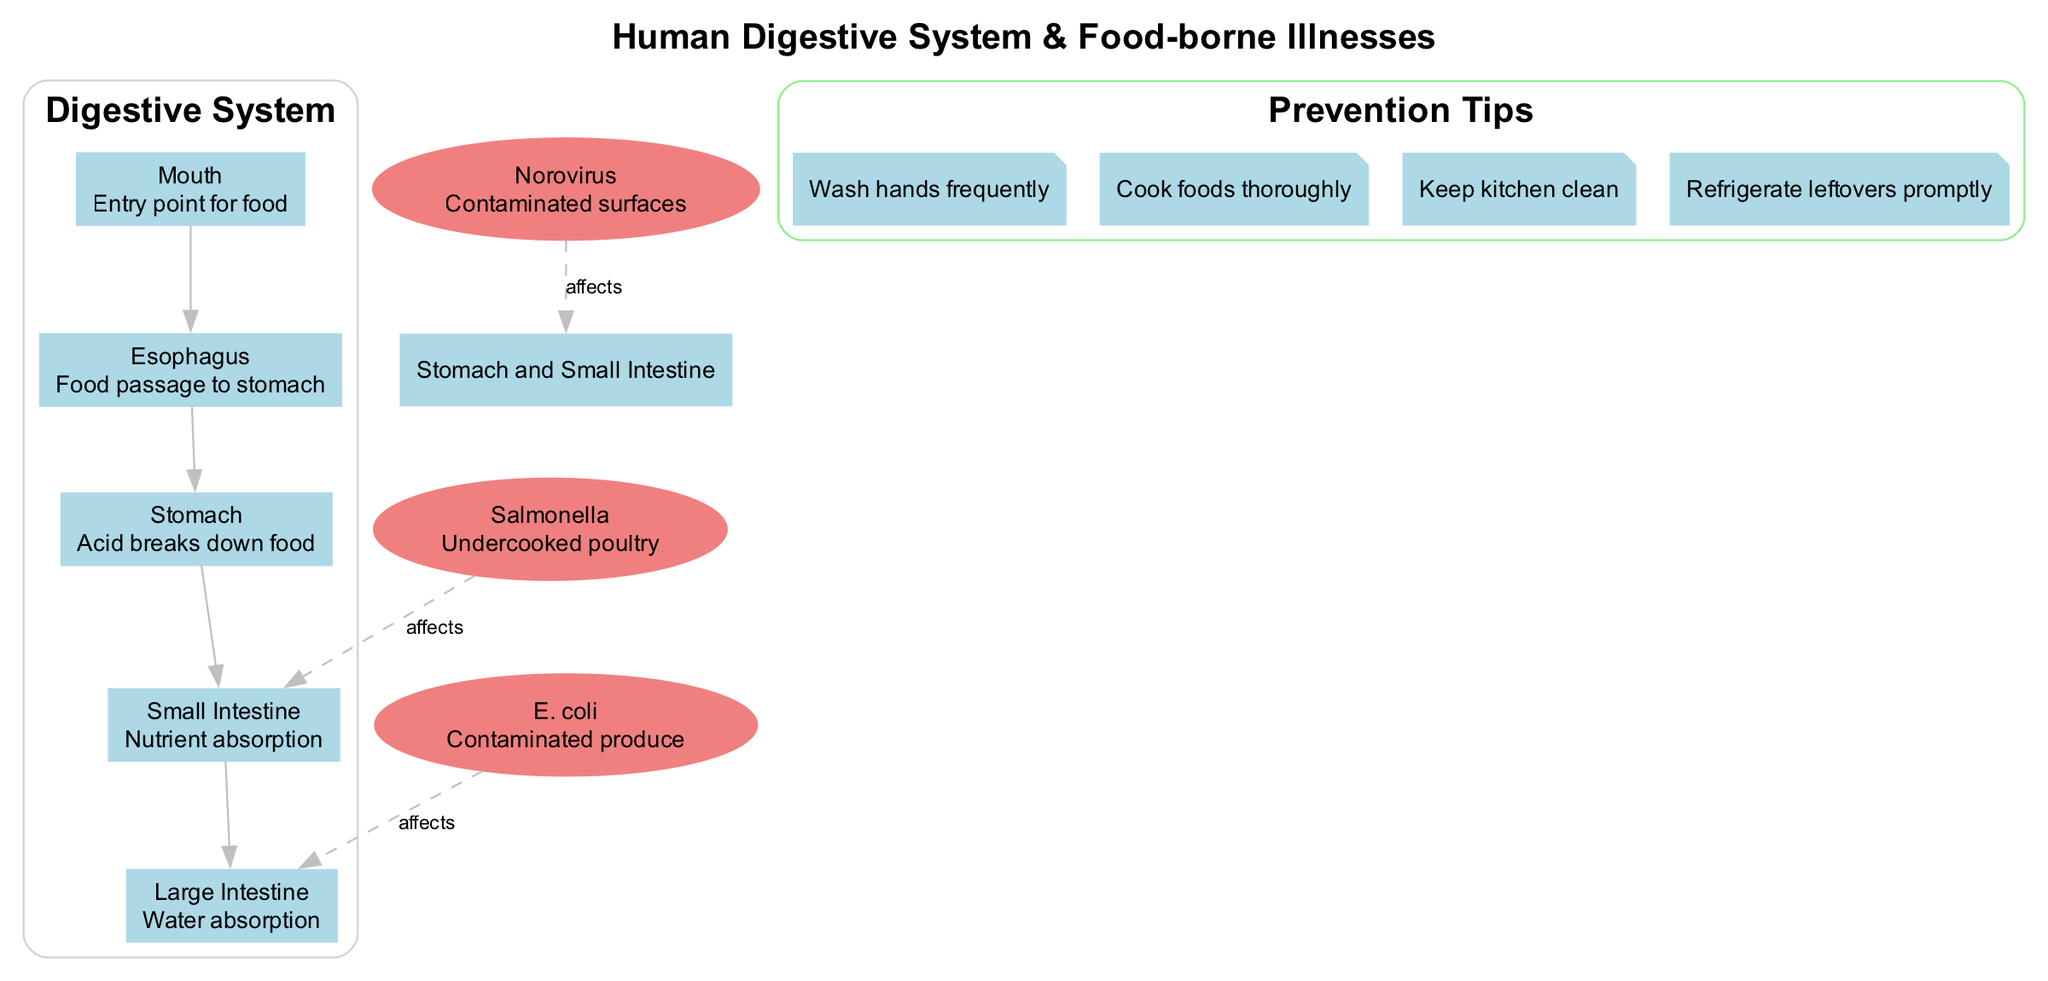What is the entry point for food in the digestive system? The diagram indicates that the "Mouth" is labeled as the entry point for food. This information is directly presented in the main components section of the diagram.
Answer: Mouth Which area is affected by Salmonella? According to the diagram, Salmonella affects the "Small Intestine." This is specifically noted under food-borne illnesses connected to the affected area.
Answer: Small Intestine How many main components are part of the digestive system? The diagram lists five main components: Mouth, Esophagus, Stomach, Small Intestine, and Large Intestine. This count is taken directly from the main components section.
Answer: Five What common source is associated with E. coli? The diagram specifies that the common source associated with E. coli is "Contaminated produce." This detail is explicitly stated next to the E. coli entry in the food-borne illnesses section.
Answer: Contaminated produce Which two areas are affected by Norovirus? The diagram shows that Norovirus affects both the "Stomach" and "Small Intestine." The connection is made by examining the information presented for Norovirus in the food-borne illnesses section.
Answer: Stomach and Small Intestine What is one prevention tip mentioned in the diagram? The diagram includes several prevention tips, one of which is "Wash hands frequently." This is listed in the prevention tips section as an important practice to prevent illnesses.
Answer: Wash hands frequently Which part of the digestive system is involved in nutrient absorption? The diagram indicates that the "Small Intestine" is responsible for nutrient absorption. This is provided as a part of the description for the main components of the digestive system.
Answer: Small Intestine What shape represents food-borne illnesses in the diagram? Food-borne illnesses are represented in the diagram with the shape of an "ellipse." This detail can be inferred from the node attributes used for those illnesses in the diagram.
Answer: Ellipse 